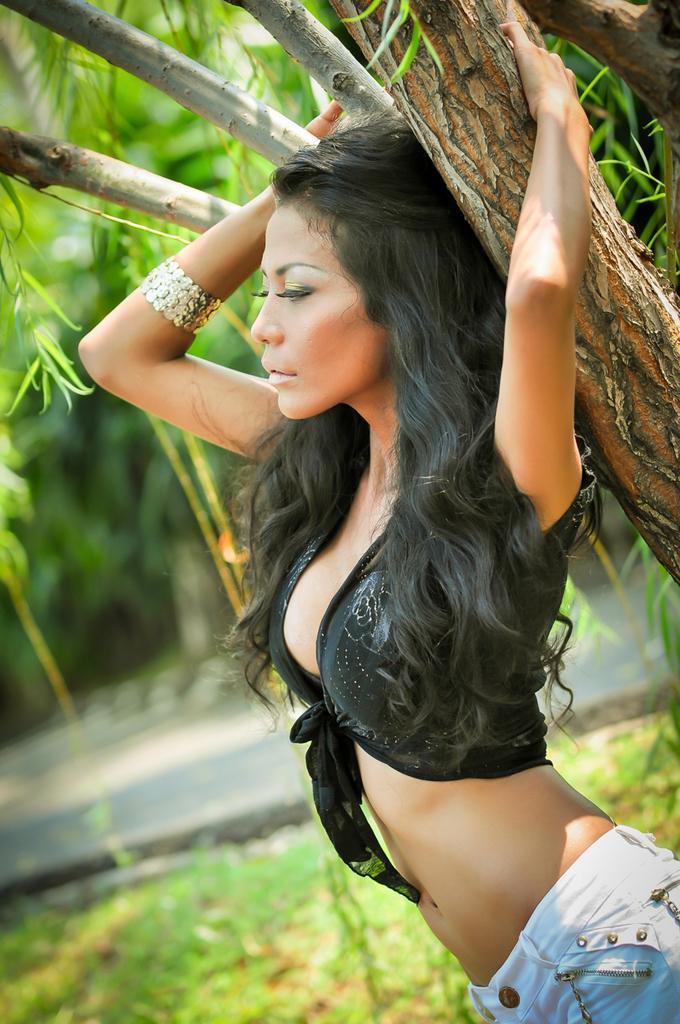How would you summarize this image in a sentence or two? In the image we can see a woman standing, wearing clothes and bracelet. Here we can see the tree, grass and the background is slightly blurred. 